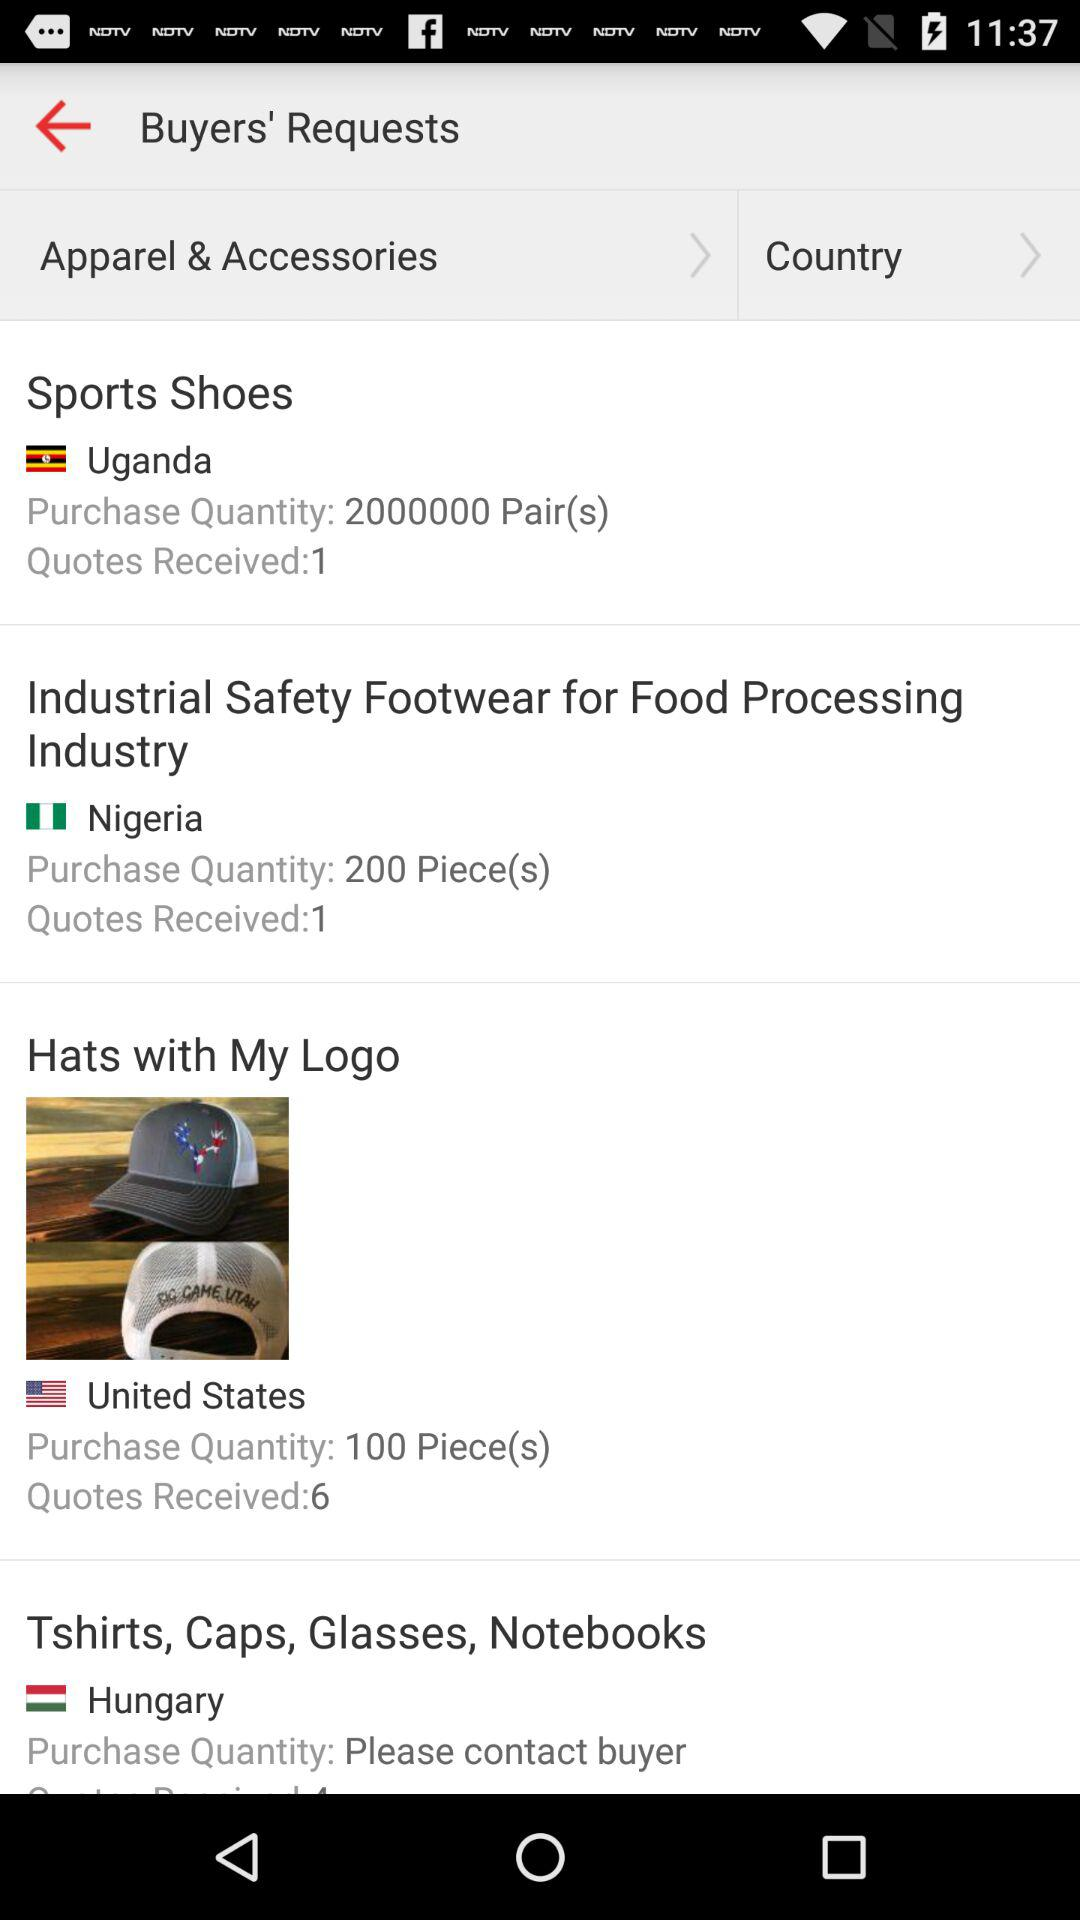What is the purchase quantity in Hungary for t-shirts, caps, glasses, and notebooks? To know the purchase quantity in Hungary for t-shirts, caps, glasses, and notebooks, please contact the buyer. 